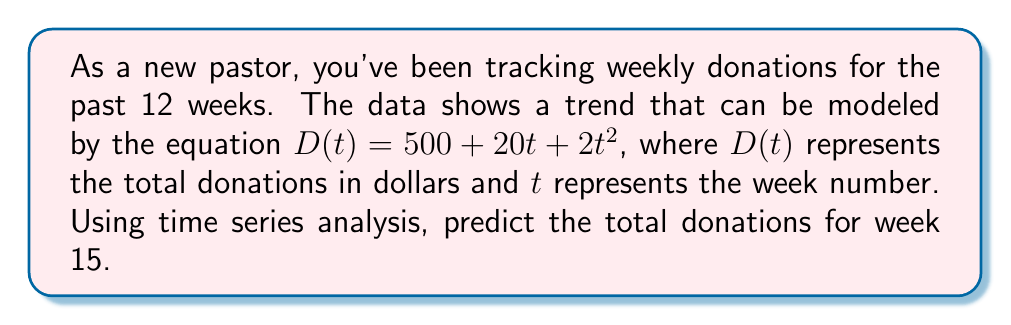Could you help me with this problem? Let's approach this step-by-step:

1) We are given the time series model:
   $D(t) = 500 + 20t + 2t^2$

2) We need to predict the donations for week 15, so we'll substitute $t = 15$ into our equation:

   $D(15) = 500 + 20(15) + 2(15)^2$

3) Let's calculate each term:
   - The constant term: 500
   - The linear term: $20(15) = 300$
   - The quadratic term: $2(15)^2 = 2(225) = 450$

4) Now, let's sum these terms:
   $D(15) = 500 + 300 + 450 = 1250$

Therefore, based on this time series analysis, we predict that the total donations for week 15 will be $1250.
Answer: $1250 